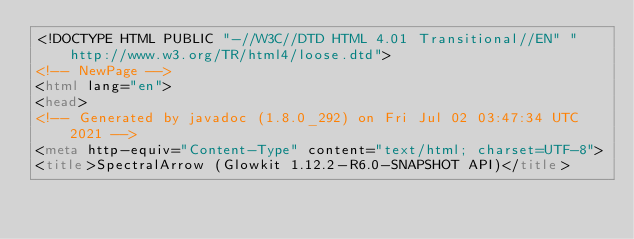<code> <loc_0><loc_0><loc_500><loc_500><_HTML_><!DOCTYPE HTML PUBLIC "-//W3C//DTD HTML 4.01 Transitional//EN" "http://www.w3.org/TR/html4/loose.dtd">
<!-- NewPage -->
<html lang="en">
<head>
<!-- Generated by javadoc (1.8.0_292) on Fri Jul 02 03:47:34 UTC 2021 -->
<meta http-equiv="Content-Type" content="text/html; charset=UTF-8">
<title>SpectralArrow (Glowkit 1.12.2-R6.0-SNAPSHOT API)</title></code> 